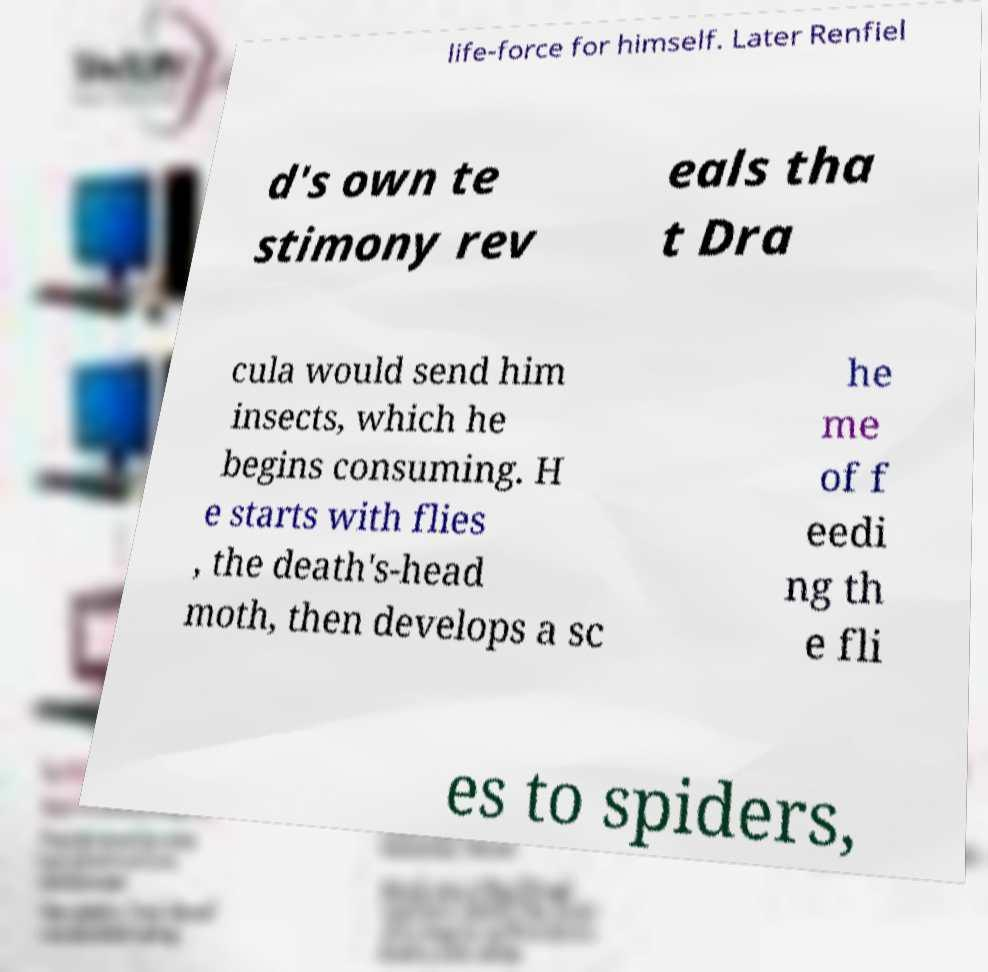Can you read and provide the text displayed in the image?This photo seems to have some interesting text. Can you extract and type it out for me? life-force for himself. Later Renfiel d's own te stimony rev eals tha t Dra cula would send him insects, which he begins consuming. H e starts with flies , the death's-head moth, then develops a sc he me of f eedi ng th e fli es to spiders, 